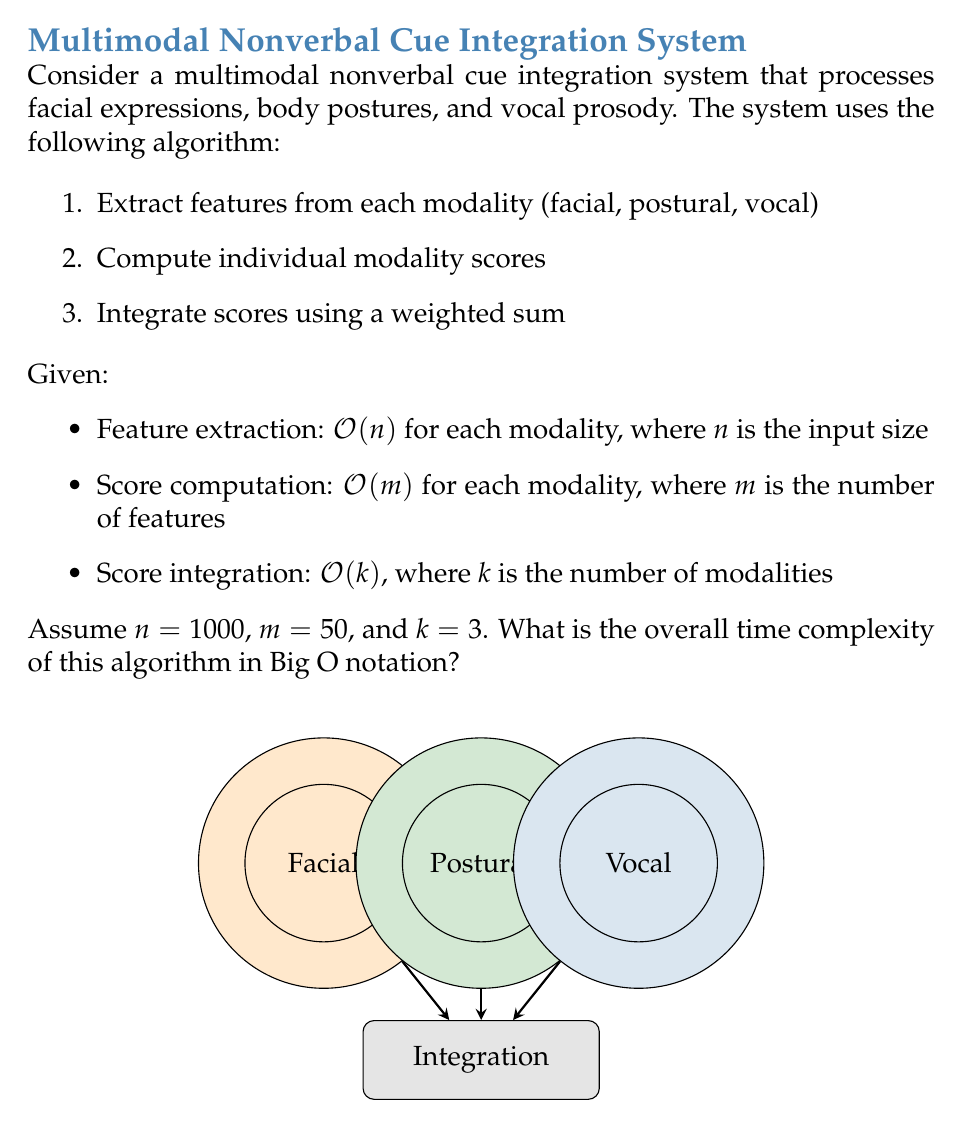Help me with this question. Let's analyze the algorithm step-by-step:

1. Feature extraction:
   - For each of the $k=3$ modalities, we perform $O(n)$ operations.
   - Total complexity for this step: $O(kn) = O(3n) = O(n)$

2. Score computation:
   - For each of the $k=3$ modalities, we perform $O(m)$ operations.
   - Total complexity for this step: $O(km) = O(3m) = O(m)$

3. Score integration:
   - This step has a complexity of $O(k)$

To find the overall time complexity, we sum these steps:
$$O(n) + O(m) + O(k)$$

Since $n = 1000$, $m = 50$, and $k = 3$, we can see that $n$ is the dominant term. Therefore, the overall time complexity simplifies to $O(n)$.

It's important to note that this simplification holds true for the given values. If $m$ were to grow significantly larger than $n$, or if $k$ were not constant, the complexity analysis would need to be adjusted accordingly.
Answer: $O(n)$ 